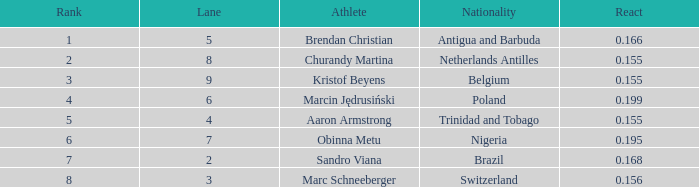How much Time has a Reaction of 0.155, and an Athlete of kristof beyens, and a Rank smaller than 3? 0.0. 